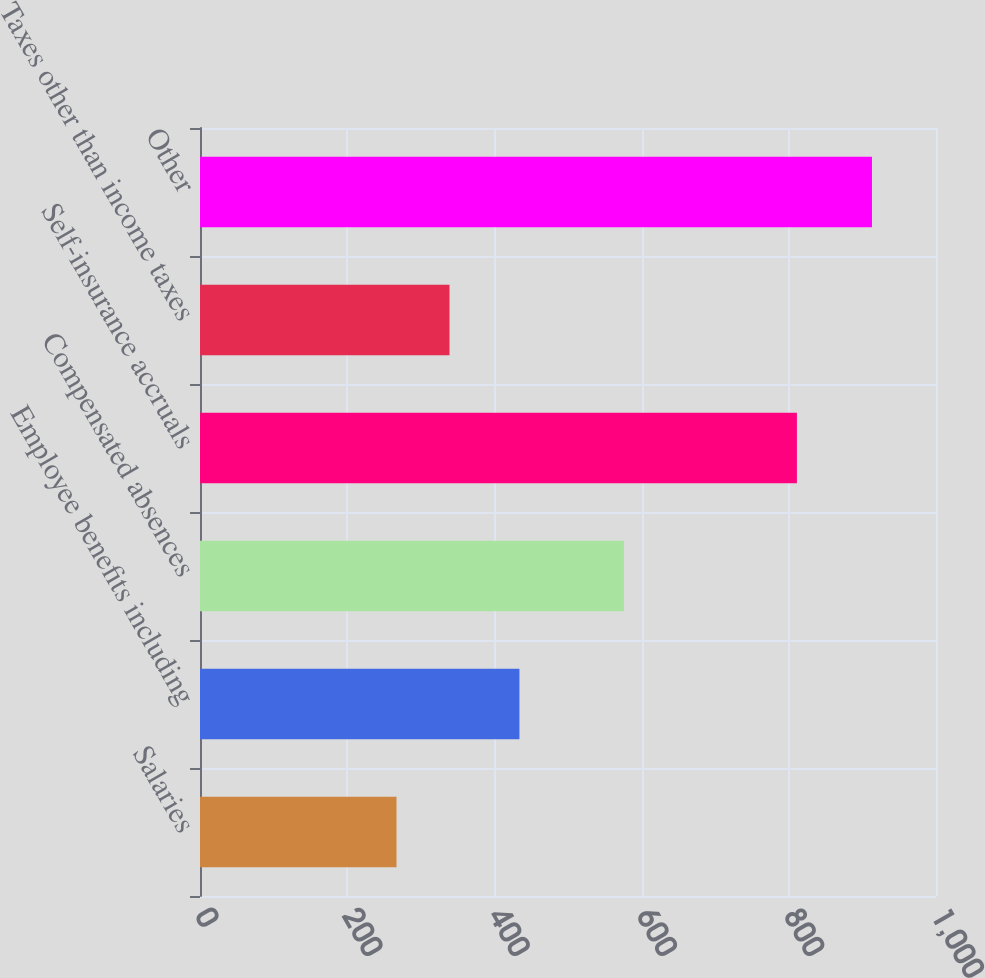<chart> <loc_0><loc_0><loc_500><loc_500><bar_chart><fcel>Salaries<fcel>Employee benefits including<fcel>Compensated absences<fcel>Self-insurance accruals<fcel>Taxes other than income taxes<fcel>Other<nl><fcel>267<fcel>434<fcel>576<fcel>811<fcel>339<fcel>913<nl></chart> 